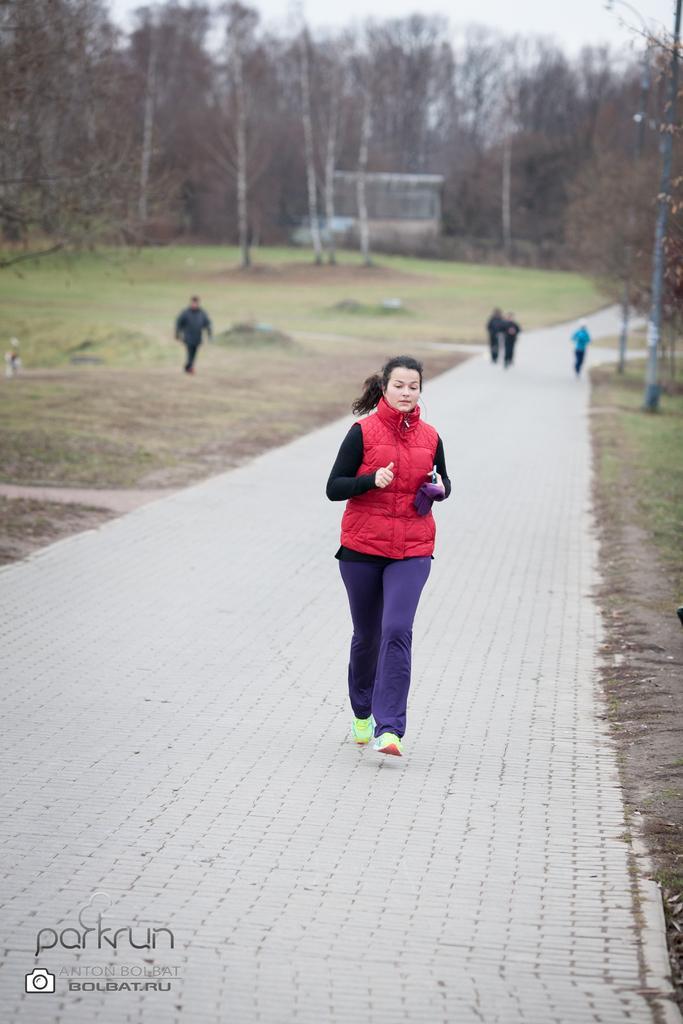Describe this image in one or two sentences. This image consists of a woman running. She is wearing red jacket. At the bottom, there is a road. To the left and right, there are trees. 